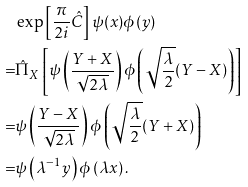Convert formula to latex. <formula><loc_0><loc_0><loc_500><loc_500>& \exp \left [ \frac { \pi } { 2 i } \hat { C } \right ] \psi ( x ) \phi ( y ) \\ = & \hat { \Pi } _ { X } \left [ \psi \left ( \frac { Y + X } { \sqrt { 2 \lambda } } \right ) \phi \left ( \sqrt { \frac { \lambda } { 2 } } ( Y - X ) \right ) \right ] \\ = & \psi \left ( \frac { Y - X } { \sqrt { 2 \lambda } } \right ) \phi \left ( \sqrt { \frac { \lambda } { 2 } } ( Y + X ) \right ) \\ = & \psi \left ( \lambda ^ { - 1 } y \right ) \phi \left ( \lambda x \right ) .</formula> 